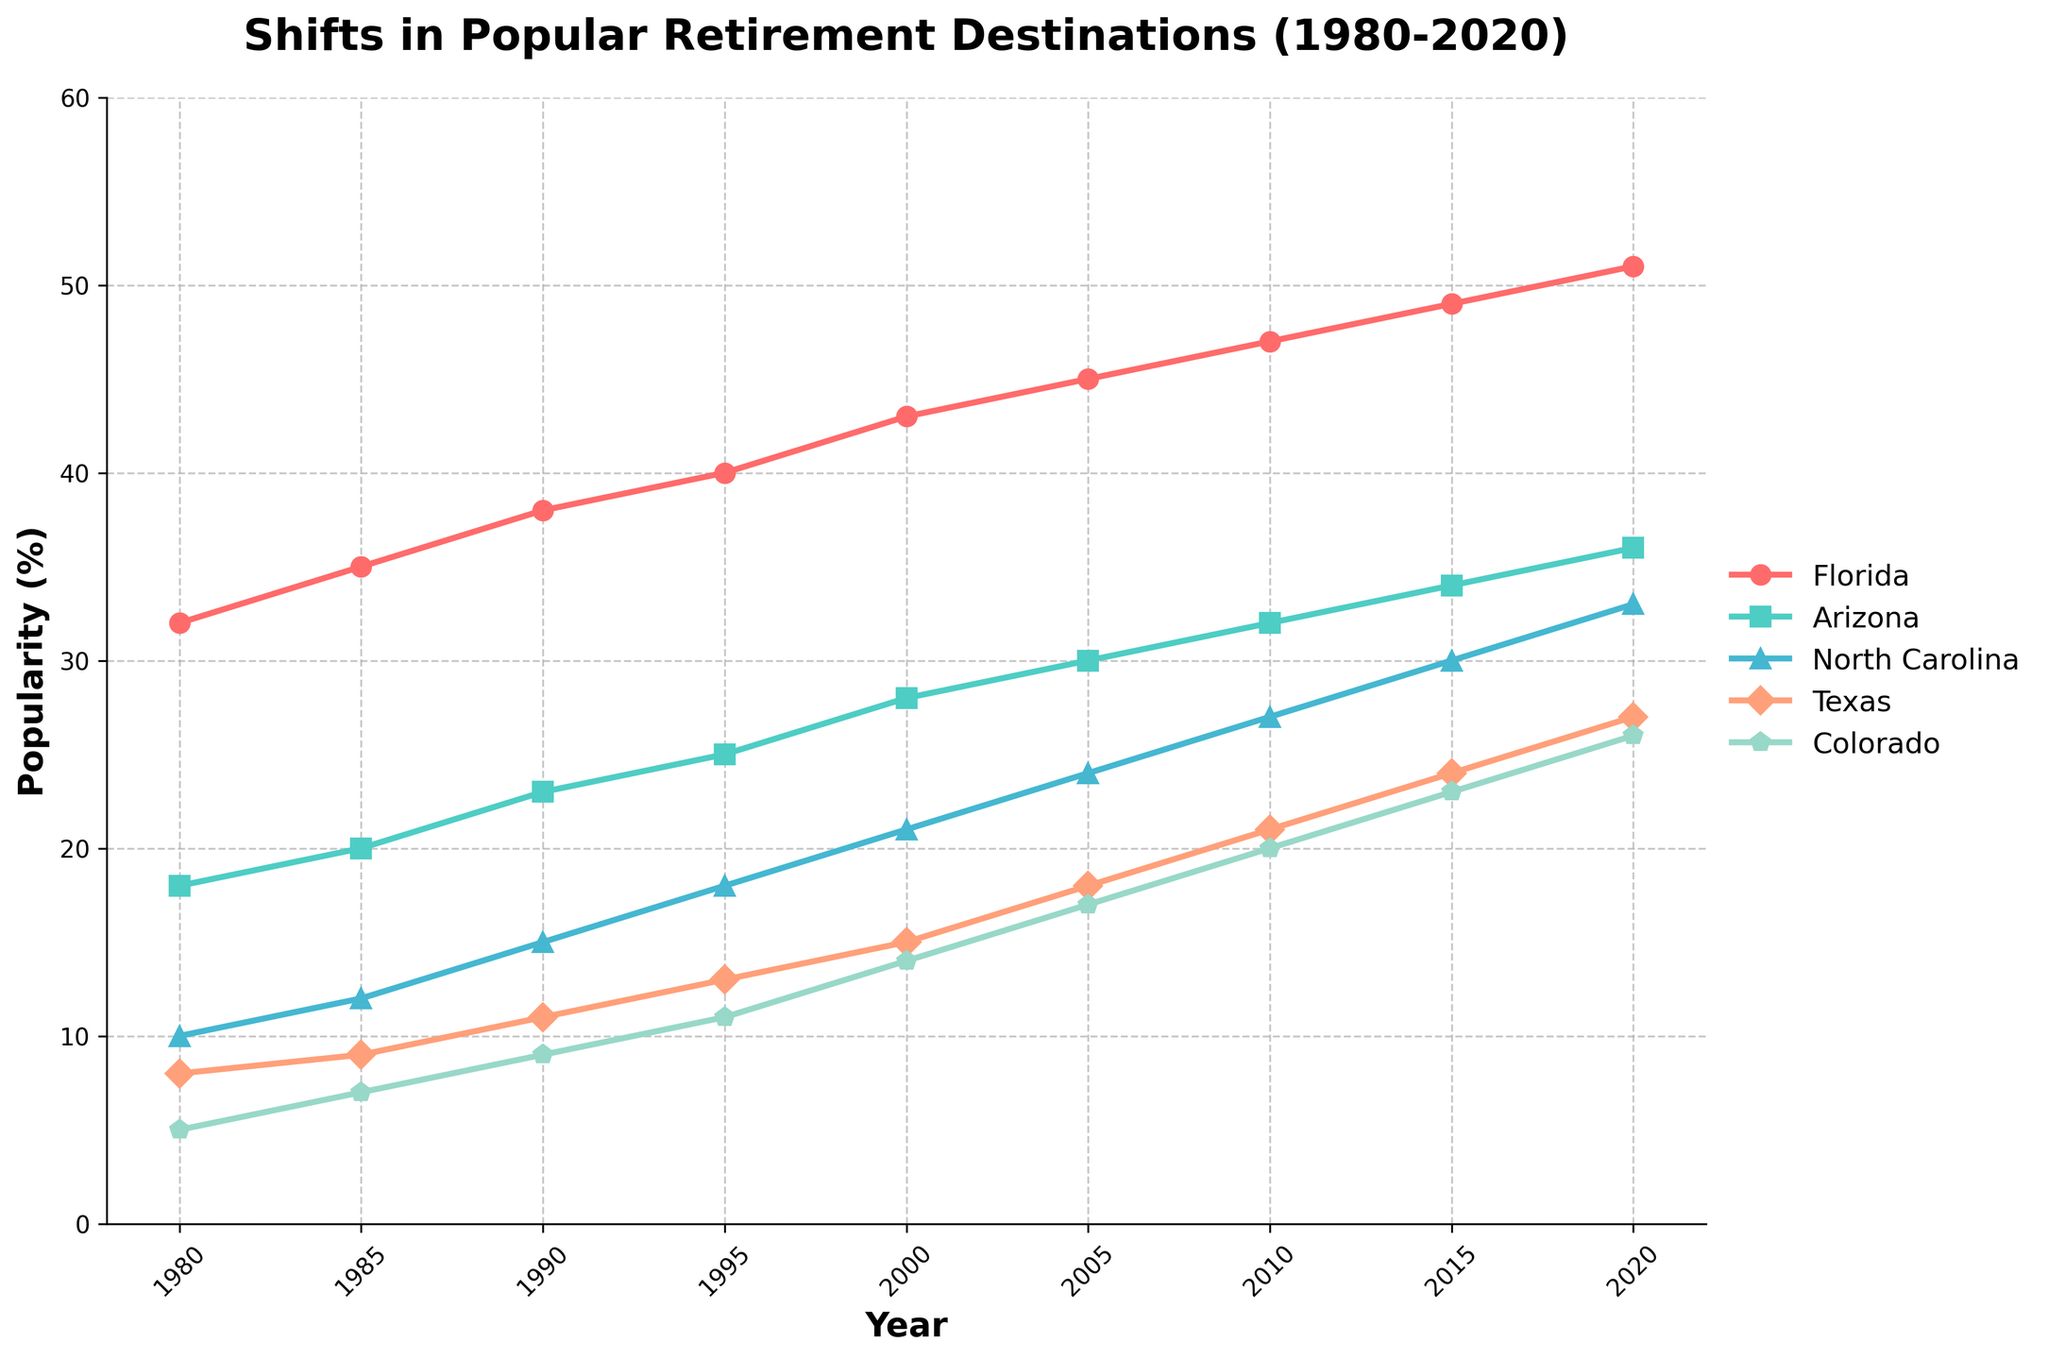Which retirement destination had the highest popularity in 1985? In 1985, looking at the highest percentage marked on the y-axis for each destination, Florida had the highest popularity with 35%.
Answer: Florida Which state showed the largest increase in popularity from 1980 to 2020? Subtract the 1980 popularity percentage from the 2020 percentage for each state. Florida: 51-32=19, Arizona: 36-18=18, North Carolina: 33-10=23, Texas: 27-8=19, Colorado: 26-5=21. North Carolina showed the largest increase of 23%.
Answer: North Carolina How did the popularity of Texas in 1990 compare to Colorado in 2000? For Texas in 1990, the popularity is 11% and for Colorado in 2000, it is 14%. Comparing the two values, Texas had a lower popularity than Colorado.
Answer: Less What's the sum of the popularity percentages of Florida and North Carolina in 2015? For Florida in 2015, it is 49% and for North Carolina it is 30%. Adding these two values, 49+30=79%.
Answer: 79% Which state had the closest popularity to 30% in 2005? Check the popularity percentages for 2005 for all states: Florida: 45%, Arizona: 30%, North Carolina: 24%, Texas: 18%, Colorado: 17%. Arizona had 30% which is exactly 30%.
Answer: Arizona What is the average popularity of Colorado over the four decades? Sum the popularity percentages of Colorado from 1980 to 2020: 5+7+9+11+14+17+20+23+26=132. Divide by the number of data points (9). The average is 132/9 ≈ 14.67.
Answer: 14.67% Between 1980 and 2020, which state consistently showed an increasing trend without any drop? By inspecting the chart, all lines should be increasing steadily year over year without any dips. Florida, Arizona, North Carolina, Texas, and Colorado all showed an increasing trend consistently.
Answer: All In what year did Arizona surpass 30% popularity? Look at the trajectory of the line representing Arizona and see when it crosses the 30% mark. In 2010, Arizona is at 32%, which is the first year it surpasses 30%.
Answer: 2010 